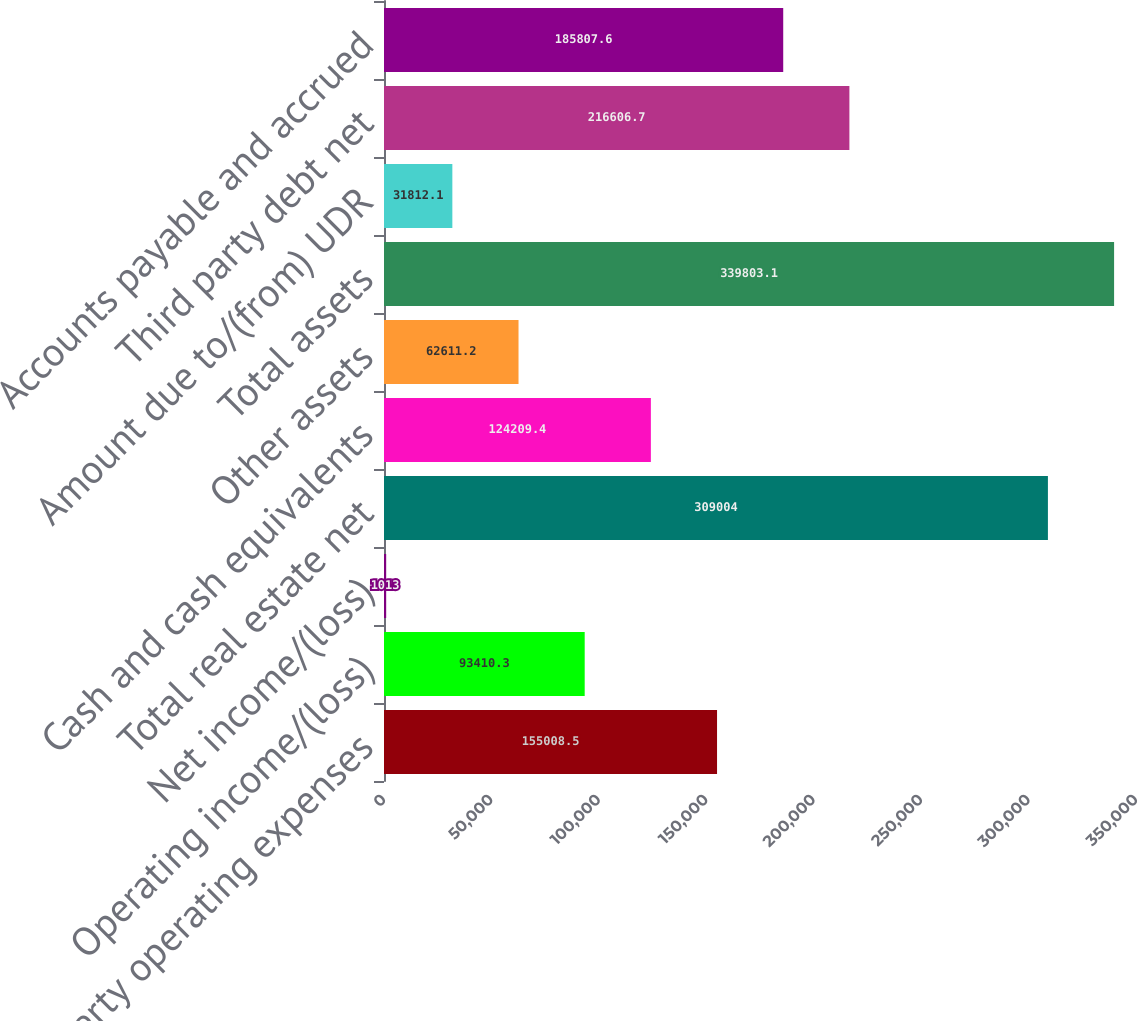Convert chart. <chart><loc_0><loc_0><loc_500><loc_500><bar_chart><fcel>Property operating expenses<fcel>Operating income/(loss)<fcel>Net income/(loss)<fcel>Total real estate net<fcel>Cash and cash equivalents<fcel>Other assets<fcel>Total assets<fcel>Amount due to/(from) UDR<fcel>Third party debt net<fcel>Accounts payable and accrued<nl><fcel>155008<fcel>93410.3<fcel>1013<fcel>309004<fcel>124209<fcel>62611.2<fcel>339803<fcel>31812.1<fcel>216607<fcel>185808<nl></chart> 